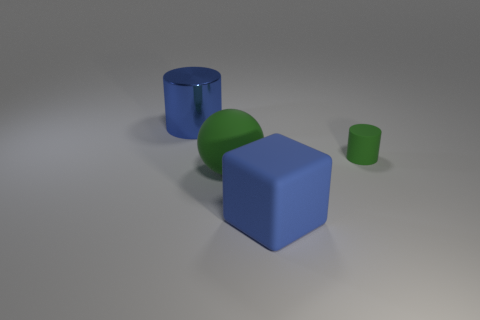How many other things are the same material as the big green ball?
Your response must be concise. 2. What shape is the object that is right of the ball and behind the large sphere?
Make the answer very short. Cylinder. There is a big block that is the same material as the green cylinder; what color is it?
Your answer should be compact. Blue. Are there the same number of blue metal cylinders behind the matte cylinder and red cubes?
Provide a succinct answer. No. There is a green thing that is the same size as the rubber block; what is its shape?
Provide a short and direct response. Sphere. What number of other objects are there of the same shape as the tiny rubber object?
Keep it short and to the point. 1. There is a blue metallic object; is it the same size as the cylinder that is right of the big blue shiny object?
Your answer should be compact. No. What number of objects are green objects that are on the right side of the blue metal cylinder or balls?
Provide a succinct answer. 2. What is the shape of the blue object in front of the large blue cylinder?
Give a very brief answer. Cube. Is the number of large blue cylinders that are to the right of the blue rubber cube the same as the number of green matte cylinders to the left of the green rubber sphere?
Offer a very short reply. Yes. 